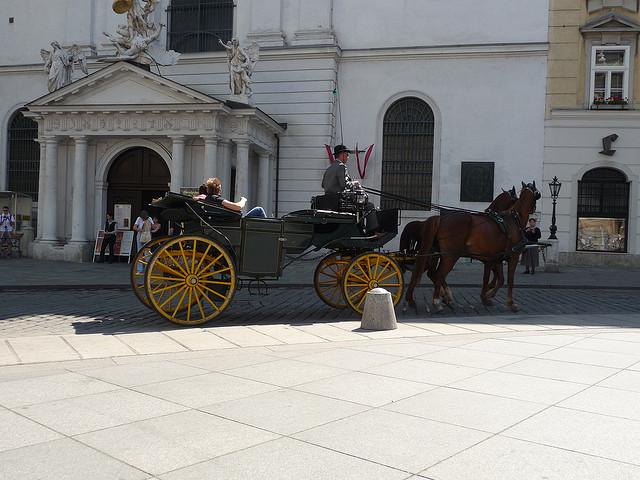What type of horses are these?
Be succinct. Brown. What color are the spokes on the buggy?
Answer briefly. Yellow. What are these people riding?
Concise answer only. Carriage. 